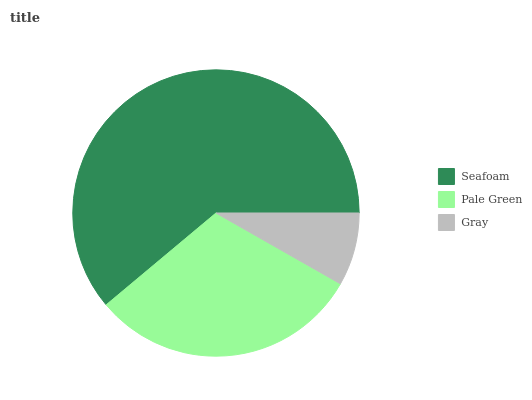Is Gray the minimum?
Answer yes or no. Yes. Is Seafoam the maximum?
Answer yes or no. Yes. Is Pale Green the minimum?
Answer yes or no. No. Is Pale Green the maximum?
Answer yes or no. No. Is Seafoam greater than Pale Green?
Answer yes or no. Yes. Is Pale Green less than Seafoam?
Answer yes or no. Yes. Is Pale Green greater than Seafoam?
Answer yes or no. No. Is Seafoam less than Pale Green?
Answer yes or no. No. Is Pale Green the high median?
Answer yes or no. Yes. Is Pale Green the low median?
Answer yes or no. Yes. Is Seafoam the high median?
Answer yes or no. No. Is Seafoam the low median?
Answer yes or no. No. 